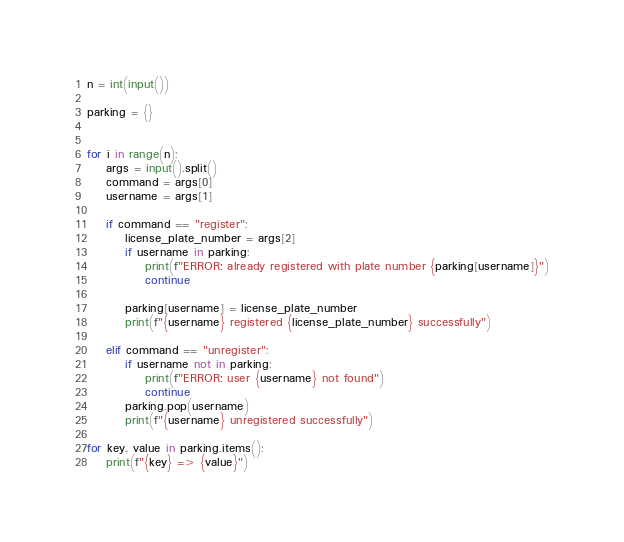Convert code to text. <code><loc_0><loc_0><loc_500><loc_500><_Python_>n = int(input())

parking = {}


for i in range(n):
    args = input().split()
    command = args[0]
    username = args[1]

    if command == "register":
        license_plate_number = args[2]
        if username in parking:
            print(f"ERROR: already registered with plate number {parking[username]}")
            continue

        parking[username] = license_plate_number
        print(f"{username} registered {license_plate_number} successfully")

    elif command == "unregister":
        if username not in parking:
            print(f"ERROR: user {username} not found")
            continue
        parking.pop(username)
        print(f"{username} unregistered successfully")

for key, value in parking.items():
    print(f"{key} => {value}")


</code> 